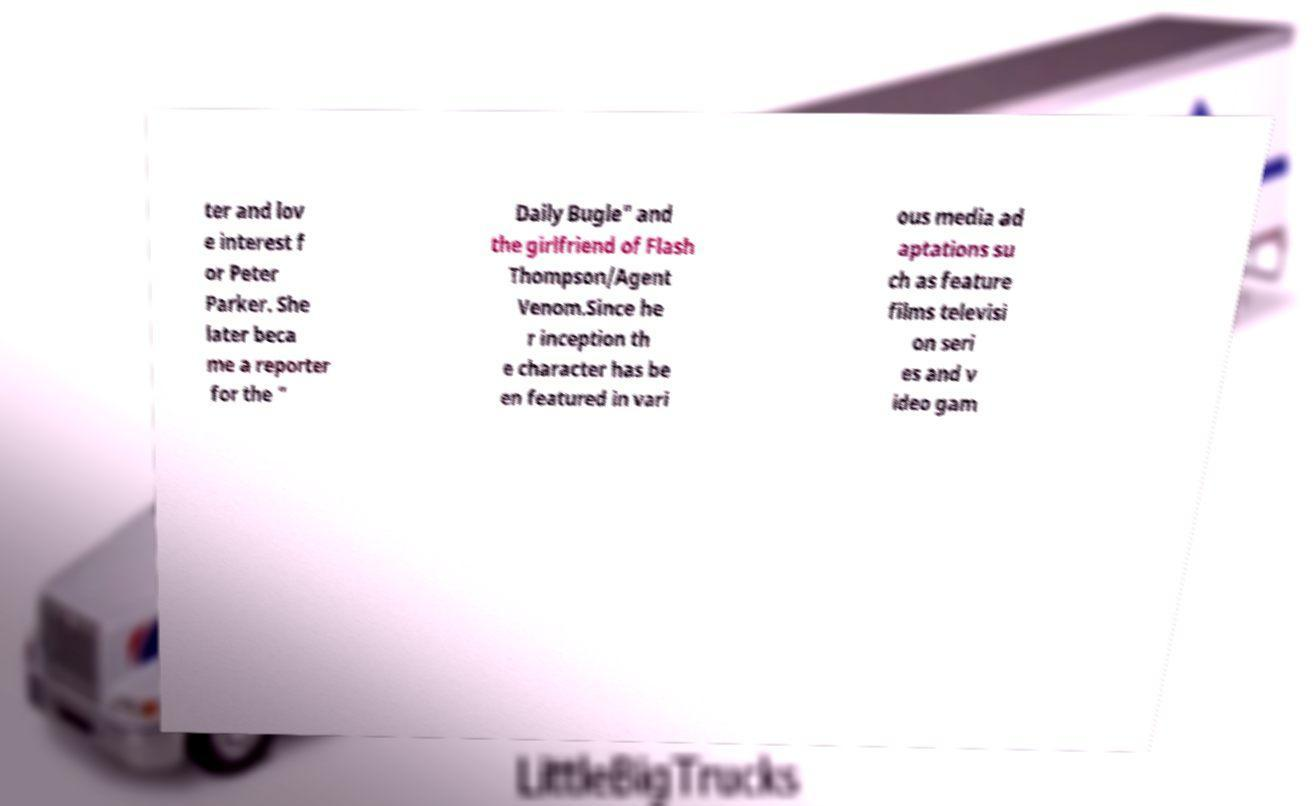Please identify and transcribe the text found in this image. ter and lov e interest f or Peter Parker. She later beca me a reporter for the " Daily Bugle" and the girlfriend of Flash Thompson/Agent Venom.Since he r inception th e character has be en featured in vari ous media ad aptations su ch as feature films televisi on seri es and v ideo gam 